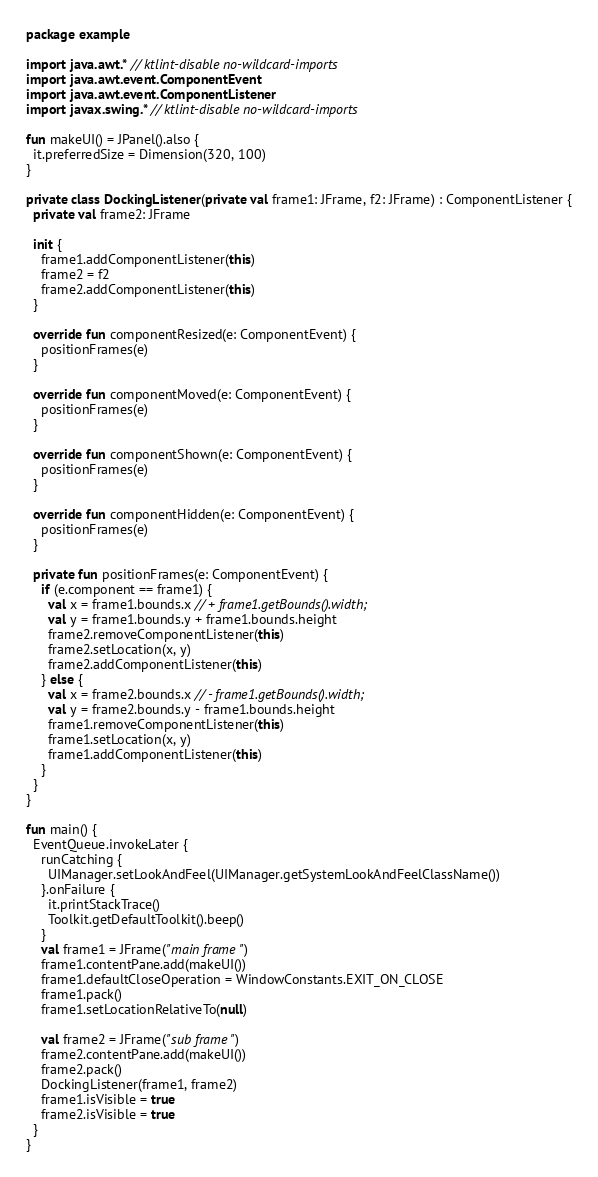<code> <loc_0><loc_0><loc_500><loc_500><_Kotlin_>package example

import java.awt.* // ktlint-disable no-wildcard-imports
import java.awt.event.ComponentEvent
import java.awt.event.ComponentListener
import javax.swing.* // ktlint-disable no-wildcard-imports

fun makeUI() = JPanel().also {
  it.preferredSize = Dimension(320, 100)
}

private class DockingListener(private val frame1: JFrame, f2: JFrame) : ComponentListener {
  private val frame2: JFrame

  init {
    frame1.addComponentListener(this)
    frame2 = f2
    frame2.addComponentListener(this)
  }

  override fun componentResized(e: ComponentEvent) {
    positionFrames(e)
  }

  override fun componentMoved(e: ComponentEvent) {
    positionFrames(e)
  }

  override fun componentShown(e: ComponentEvent) {
    positionFrames(e)
  }

  override fun componentHidden(e: ComponentEvent) {
    positionFrames(e)
  }

  private fun positionFrames(e: ComponentEvent) {
    if (e.component == frame1) {
      val x = frame1.bounds.x // + frame1.getBounds().width;
      val y = frame1.bounds.y + frame1.bounds.height
      frame2.removeComponentListener(this)
      frame2.setLocation(x, y)
      frame2.addComponentListener(this)
    } else {
      val x = frame2.bounds.x // - frame1.getBounds().width;
      val y = frame2.bounds.y - frame1.bounds.height
      frame1.removeComponentListener(this)
      frame1.setLocation(x, y)
      frame1.addComponentListener(this)
    }
  }
}

fun main() {
  EventQueue.invokeLater {
    runCatching {
      UIManager.setLookAndFeel(UIManager.getSystemLookAndFeelClassName())
    }.onFailure {
      it.printStackTrace()
      Toolkit.getDefaultToolkit().beep()
    }
    val frame1 = JFrame("main frame")
    frame1.contentPane.add(makeUI())
    frame1.defaultCloseOperation = WindowConstants.EXIT_ON_CLOSE
    frame1.pack()
    frame1.setLocationRelativeTo(null)

    val frame2 = JFrame("sub frame")
    frame2.contentPane.add(makeUI())
    frame2.pack()
    DockingListener(frame1, frame2)
    frame1.isVisible = true
    frame2.isVisible = true
  }
}
</code> 